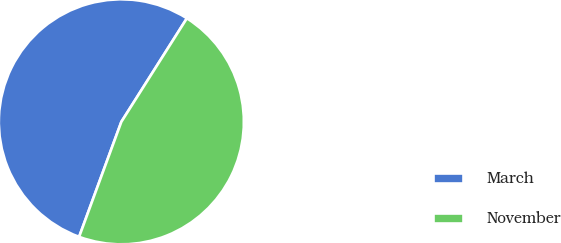<chart> <loc_0><loc_0><loc_500><loc_500><pie_chart><fcel>March<fcel>November<nl><fcel>53.38%<fcel>46.62%<nl></chart> 